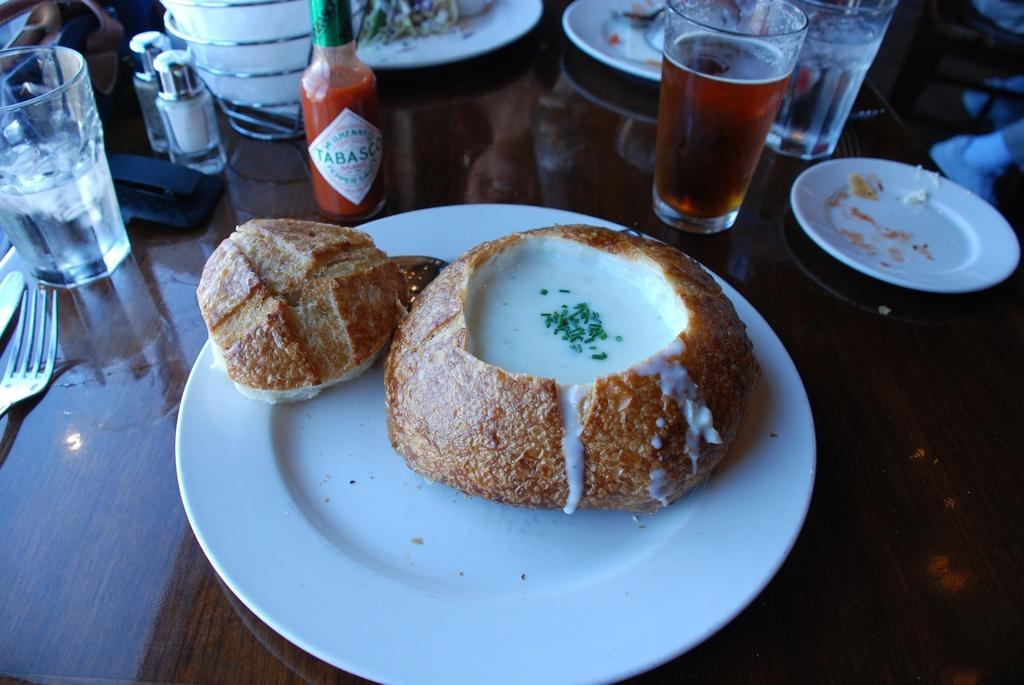What type of surface is visible in the image? There is a wooden surface in the image. What is placed on the wooden surface? There are white plates on the wooden surface. What can be found inside the white plates? There are food items in the white plates. What utensil is visible in the image? There is a fork visible in the image. What type of containers are present in the image? There are glasses and bottles in the image. Are there any other items visible in the image besides those mentioned? Yes, there are other unspecified items in the image. Can you see a cub walking in the image? No, there is no cub or any indication of walking in the image. 